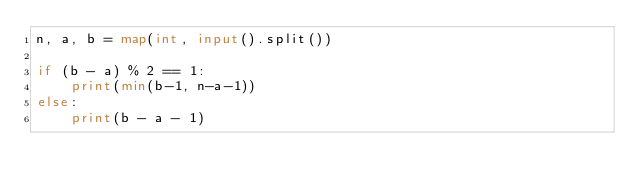<code> <loc_0><loc_0><loc_500><loc_500><_Python_>n, a, b = map(int, input().split())

if (b - a) % 2 == 1:
    print(min(b-1, n-a-1))
else:
    print(b - a - 1)</code> 